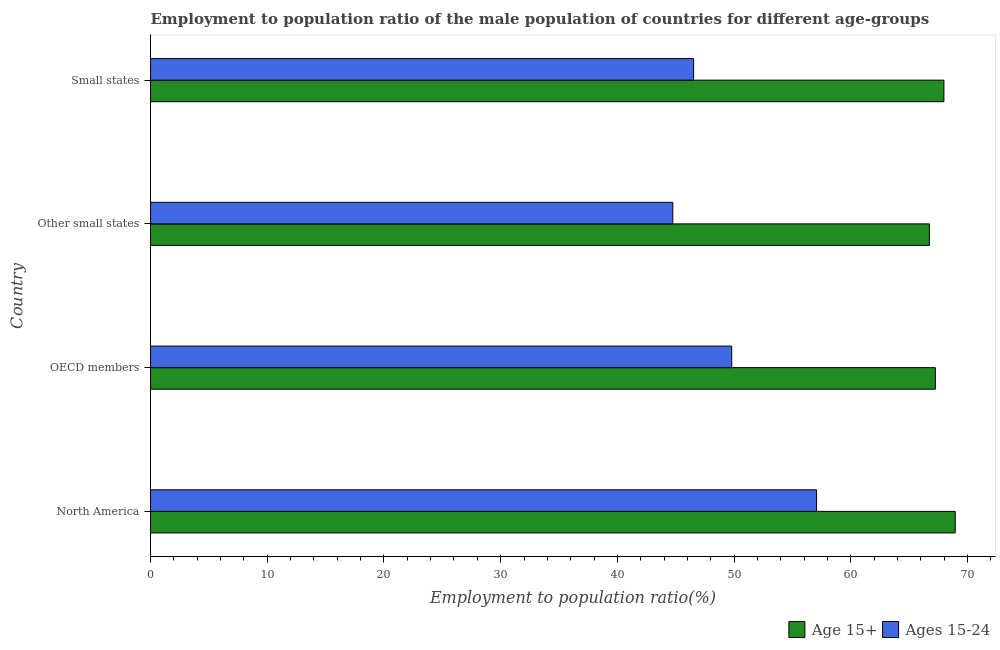How many different coloured bars are there?
Give a very brief answer. 2. How many bars are there on the 4th tick from the bottom?
Your answer should be very brief. 2. What is the label of the 3rd group of bars from the top?
Your answer should be very brief. OECD members. In how many cases, is the number of bars for a given country not equal to the number of legend labels?
Your answer should be very brief. 0. What is the employment to population ratio(age 15-24) in Other small states?
Your answer should be compact. 44.75. Across all countries, what is the maximum employment to population ratio(age 15-24)?
Make the answer very short. 57.07. Across all countries, what is the minimum employment to population ratio(age 15-24)?
Your answer should be compact. 44.75. In which country was the employment to population ratio(age 15-24) minimum?
Your response must be concise. Other small states. What is the total employment to population ratio(age 15-24) in the graph?
Keep it short and to the point. 198.15. What is the difference between the employment to population ratio(age 15-24) in Other small states and that in Small states?
Make the answer very short. -1.78. What is the difference between the employment to population ratio(age 15+) in Small states and the employment to population ratio(age 15-24) in Other small states?
Your response must be concise. 23.23. What is the average employment to population ratio(age 15+) per country?
Keep it short and to the point. 67.73. What is the difference between the employment to population ratio(age 15-24) and employment to population ratio(age 15+) in OECD members?
Your response must be concise. -17.45. What is the ratio of the employment to population ratio(age 15+) in Other small states to that in Small states?
Your answer should be very brief. 0.98. What is the difference between the highest and the second highest employment to population ratio(age 15-24)?
Provide a succinct answer. 7.27. What is the difference between the highest and the lowest employment to population ratio(age 15+)?
Your answer should be very brief. 2.22. In how many countries, is the employment to population ratio(age 15+) greater than the average employment to population ratio(age 15+) taken over all countries?
Your answer should be very brief. 2. What does the 1st bar from the top in Small states represents?
Offer a very short reply. Ages 15-24. What does the 2nd bar from the bottom in OECD members represents?
Your answer should be very brief. Ages 15-24. Are all the bars in the graph horizontal?
Provide a short and direct response. Yes. How many countries are there in the graph?
Your answer should be compact. 4. What is the difference between two consecutive major ticks on the X-axis?
Provide a succinct answer. 10. Does the graph contain any zero values?
Ensure brevity in your answer.  No. How many legend labels are there?
Your answer should be very brief. 2. What is the title of the graph?
Make the answer very short. Employment to population ratio of the male population of countries for different age-groups. What is the label or title of the X-axis?
Your answer should be very brief. Employment to population ratio(%). What is the Employment to population ratio(%) of Age 15+ in North America?
Provide a succinct answer. 68.95. What is the Employment to population ratio(%) of Ages 15-24 in North America?
Your answer should be compact. 57.07. What is the Employment to population ratio(%) in Age 15+ in OECD members?
Offer a very short reply. 67.24. What is the Employment to population ratio(%) in Ages 15-24 in OECD members?
Provide a succinct answer. 49.8. What is the Employment to population ratio(%) in Age 15+ in Other small states?
Give a very brief answer. 66.73. What is the Employment to population ratio(%) in Ages 15-24 in Other small states?
Your answer should be very brief. 44.75. What is the Employment to population ratio(%) in Age 15+ in Small states?
Ensure brevity in your answer.  67.98. What is the Employment to population ratio(%) in Ages 15-24 in Small states?
Your answer should be very brief. 46.53. Across all countries, what is the maximum Employment to population ratio(%) of Age 15+?
Keep it short and to the point. 68.95. Across all countries, what is the maximum Employment to population ratio(%) of Ages 15-24?
Make the answer very short. 57.07. Across all countries, what is the minimum Employment to population ratio(%) in Age 15+?
Your answer should be compact. 66.73. Across all countries, what is the minimum Employment to population ratio(%) of Ages 15-24?
Keep it short and to the point. 44.75. What is the total Employment to population ratio(%) of Age 15+ in the graph?
Your answer should be compact. 270.91. What is the total Employment to population ratio(%) in Ages 15-24 in the graph?
Provide a succinct answer. 198.15. What is the difference between the Employment to population ratio(%) of Age 15+ in North America and that in OECD members?
Offer a terse response. 1.71. What is the difference between the Employment to population ratio(%) of Ages 15-24 in North America and that in OECD members?
Ensure brevity in your answer.  7.27. What is the difference between the Employment to population ratio(%) of Age 15+ in North America and that in Other small states?
Give a very brief answer. 2.22. What is the difference between the Employment to population ratio(%) of Ages 15-24 in North America and that in Other small states?
Offer a very short reply. 12.32. What is the difference between the Employment to population ratio(%) of Ages 15-24 in North America and that in Small states?
Your answer should be compact. 10.54. What is the difference between the Employment to population ratio(%) in Age 15+ in OECD members and that in Other small states?
Your answer should be very brief. 0.51. What is the difference between the Employment to population ratio(%) in Ages 15-24 in OECD members and that in Other small states?
Give a very brief answer. 5.05. What is the difference between the Employment to population ratio(%) of Age 15+ in OECD members and that in Small states?
Ensure brevity in your answer.  -0.73. What is the difference between the Employment to population ratio(%) in Ages 15-24 in OECD members and that in Small states?
Your answer should be compact. 3.27. What is the difference between the Employment to population ratio(%) of Age 15+ in Other small states and that in Small states?
Your answer should be compact. -1.25. What is the difference between the Employment to population ratio(%) of Ages 15-24 in Other small states and that in Small states?
Your response must be concise. -1.78. What is the difference between the Employment to population ratio(%) of Age 15+ in North America and the Employment to population ratio(%) of Ages 15-24 in OECD members?
Give a very brief answer. 19.15. What is the difference between the Employment to population ratio(%) in Age 15+ in North America and the Employment to population ratio(%) in Ages 15-24 in Other small states?
Keep it short and to the point. 24.2. What is the difference between the Employment to population ratio(%) in Age 15+ in North America and the Employment to population ratio(%) in Ages 15-24 in Small states?
Your answer should be compact. 22.42. What is the difference between the Employment to population ratio(%) of Age 15+ in OECD members and the Employment to population ratio(%) of Ages 15-24 in Other small states?
Your response must be concise. 22.5. What is the difference between the Employment to population ratio(%) in Age 15+ in OECD members and the Employment to population ratio(%) in Ages 15-24 in Small states?
Offer a very short reply. 20.71. What is the difference between the Employment to population ratio(%) in Age 15+ in Other small states and the Employment to population ratio(%) in Ages 15-24 in Small states?
Provide a short and direct response. 20.2. What is the average Employment to population ratio(%) of Age 15+ per country?
Offer a very short reply. 67.73. What is the average Employment to population ratio(%) of Ages 15-24 per country?
Offer a very short reply. 49.54. What is the difference between the Employment to population ratio(%) in Age 15+ and Employment to population ratio(%) in Ages 15-24 in North America?
Give a very brief answer. 11.88. What is the difference between the Employment to population ratio(%) of Age 15+ and Employment to population ratio(%) of Ages 15-24 in OECD members?
Your answer should be compact. 17.45. What is the difference between the Employment to population ratio(%) in Age 15+ and Employment to population ratio(%) in Ages 15-24 in Other small states?
Keep it short and to the point. 21.98. What is the difference between the Employment to population ratio(%) of Age 15+ and Employment to population ratio(%) of Ages 15-24 in Small states?
Your answer should be compact. 21.45. What is the ratio of the Employment to population ratio(%) of Age 15+ in North America to that in OECD members?
Offer a very short reply. 1.03. What is the ratio of the Employment to population ratio(%) of Ages 15-24 in North America to that in OECD members?
Make the answer very short. 1.15. What is the ratio of the Employment to population ratio(%) of Age 15+ in North America to that in Other small states?
Your answer should be compact. 1.03. What is the ratio of the Employment to population ratio(%) of Ages 15-24 in North America to that in Other small states?
Ensure brevity in your answer.  1.28. What is the ratio of the Employment to population ratio(%) of Age 15+ in North America to that in Small states?
Your answer should be compact. 1.01. What is the ratio of the Employment to population ratio(%) in Ages 15-24 in North America to that in Small states?
Keep it short and to the point. 1.23. What is the ratio of the Employment to population ratio(%) of Age 15+ in OECD members to that in Other small states?
Provide a short and direct response. 1.01. What is the ratio of the Employment to population ratio(%) in Ages 15-24 in OECD members to that in Other small states?
Your answer should be very brief. 1.11. What is the ratio of the Employment to population ratio(%) of Age 15+ in OECD members to that in Small states?
Provide a succinct answer. 0.99. What is the ratio of the Employment to population ratio(%) in Ages 15-24 in OECD members to that in Small states?
Give a very brief answer. 1.07. What is the ratio of the Employment to population ratio(%) in Age 15+ in Other small states to that in Small states?
Your response must be concise. 0.98. What is the ratio of the Employment to population ratio(%) in Ages 15-24 in Other small states to that in Small states?
Offer a terse response. 0.96. What is the difference between the highest and the second highest Employment to population ratio(%) of Ages 15-24?
Your response must be concise. 7.27. What is the difference between the highest and the lowest Employment to population ratio(%) in Age 15+?
Give a very brief answer. 2.22. What is the difference between the highest and the lowest Employment to population ratio(%) of Ages 15-24?
Provide a succinct answer. 12.32. 